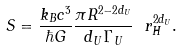Convert formula to latex. <formula><loc_0><loc_0><loc_500><loc_500>S = \frac { k _ { B } c ^ { 3 } } { \hbar { G } } \frac { \pi R ^ { 2 - 2 d _ { U } } } { d _ { U } \Gamma _ { U } } \ r _ { H } ^ { 2 d _ { U } } .</formula> 